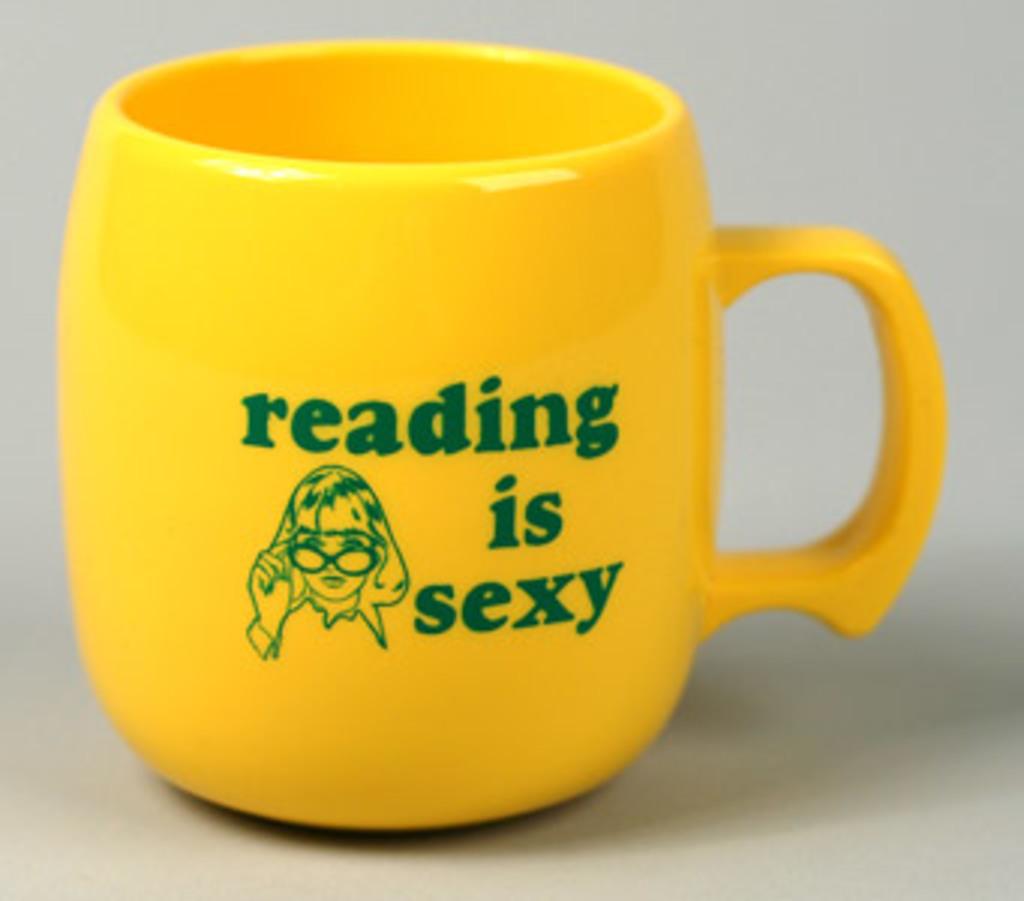What is the women wearing on her face?
Give a very brief answer. Answering does not require reading text in the image. Reading is what?
Offer a very short reply. Sexy. 